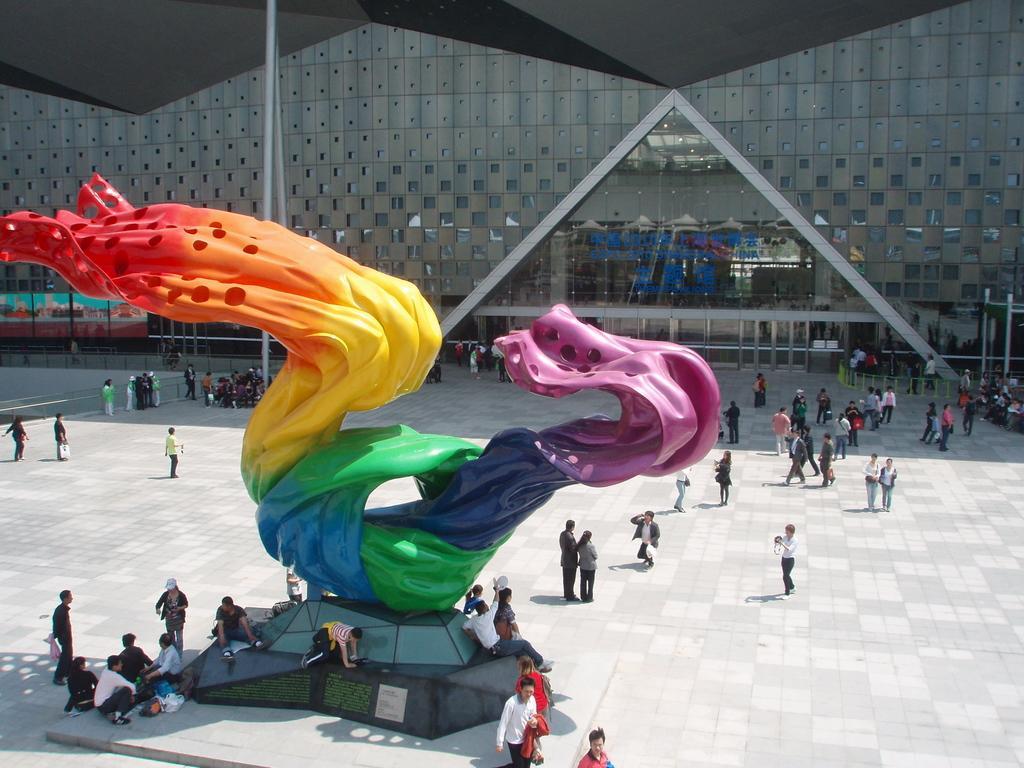How would you summarize this image in a sentence or two? In this image I can see group of people some are sitting and some are standing, in front I can see a statue in multi color. Background I can see a glass window. 